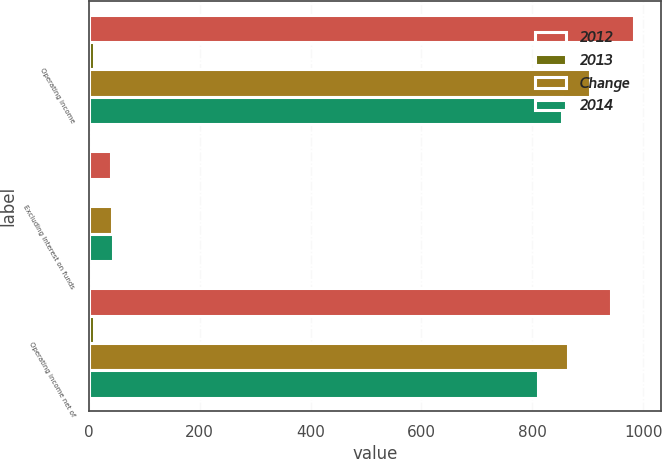Convert chart to OTSL. <chart><loc_0><loc_0><loc_500><loc_500><stacked_bar_chart><ecel><fcel>Operating income<fcel>Excluding Interest on funds<fcel>Operating income net of<nl><fcel>2012<fcel>982.7<fcel>40.7<fcel>942<nl><fcel>2013<fcel>9<fcel>1<fcel>9<nl><fcel>Change<fcel>904.8<fcel>41<fcel>863.8<nl><fcel>2014<fcel>853.9<fcel>43.6<fcel>810.3<nl></chart> 